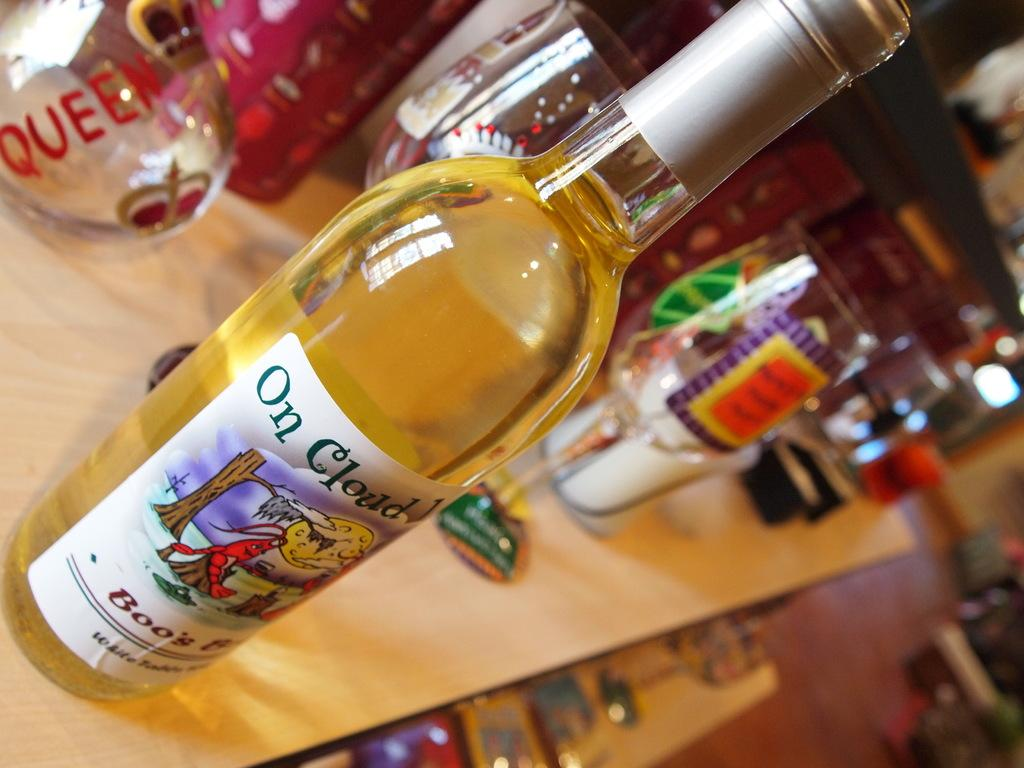<image>
Summarize the visual content of the image. A bottle of cloud 1 beer is on a table with wine glasses. 